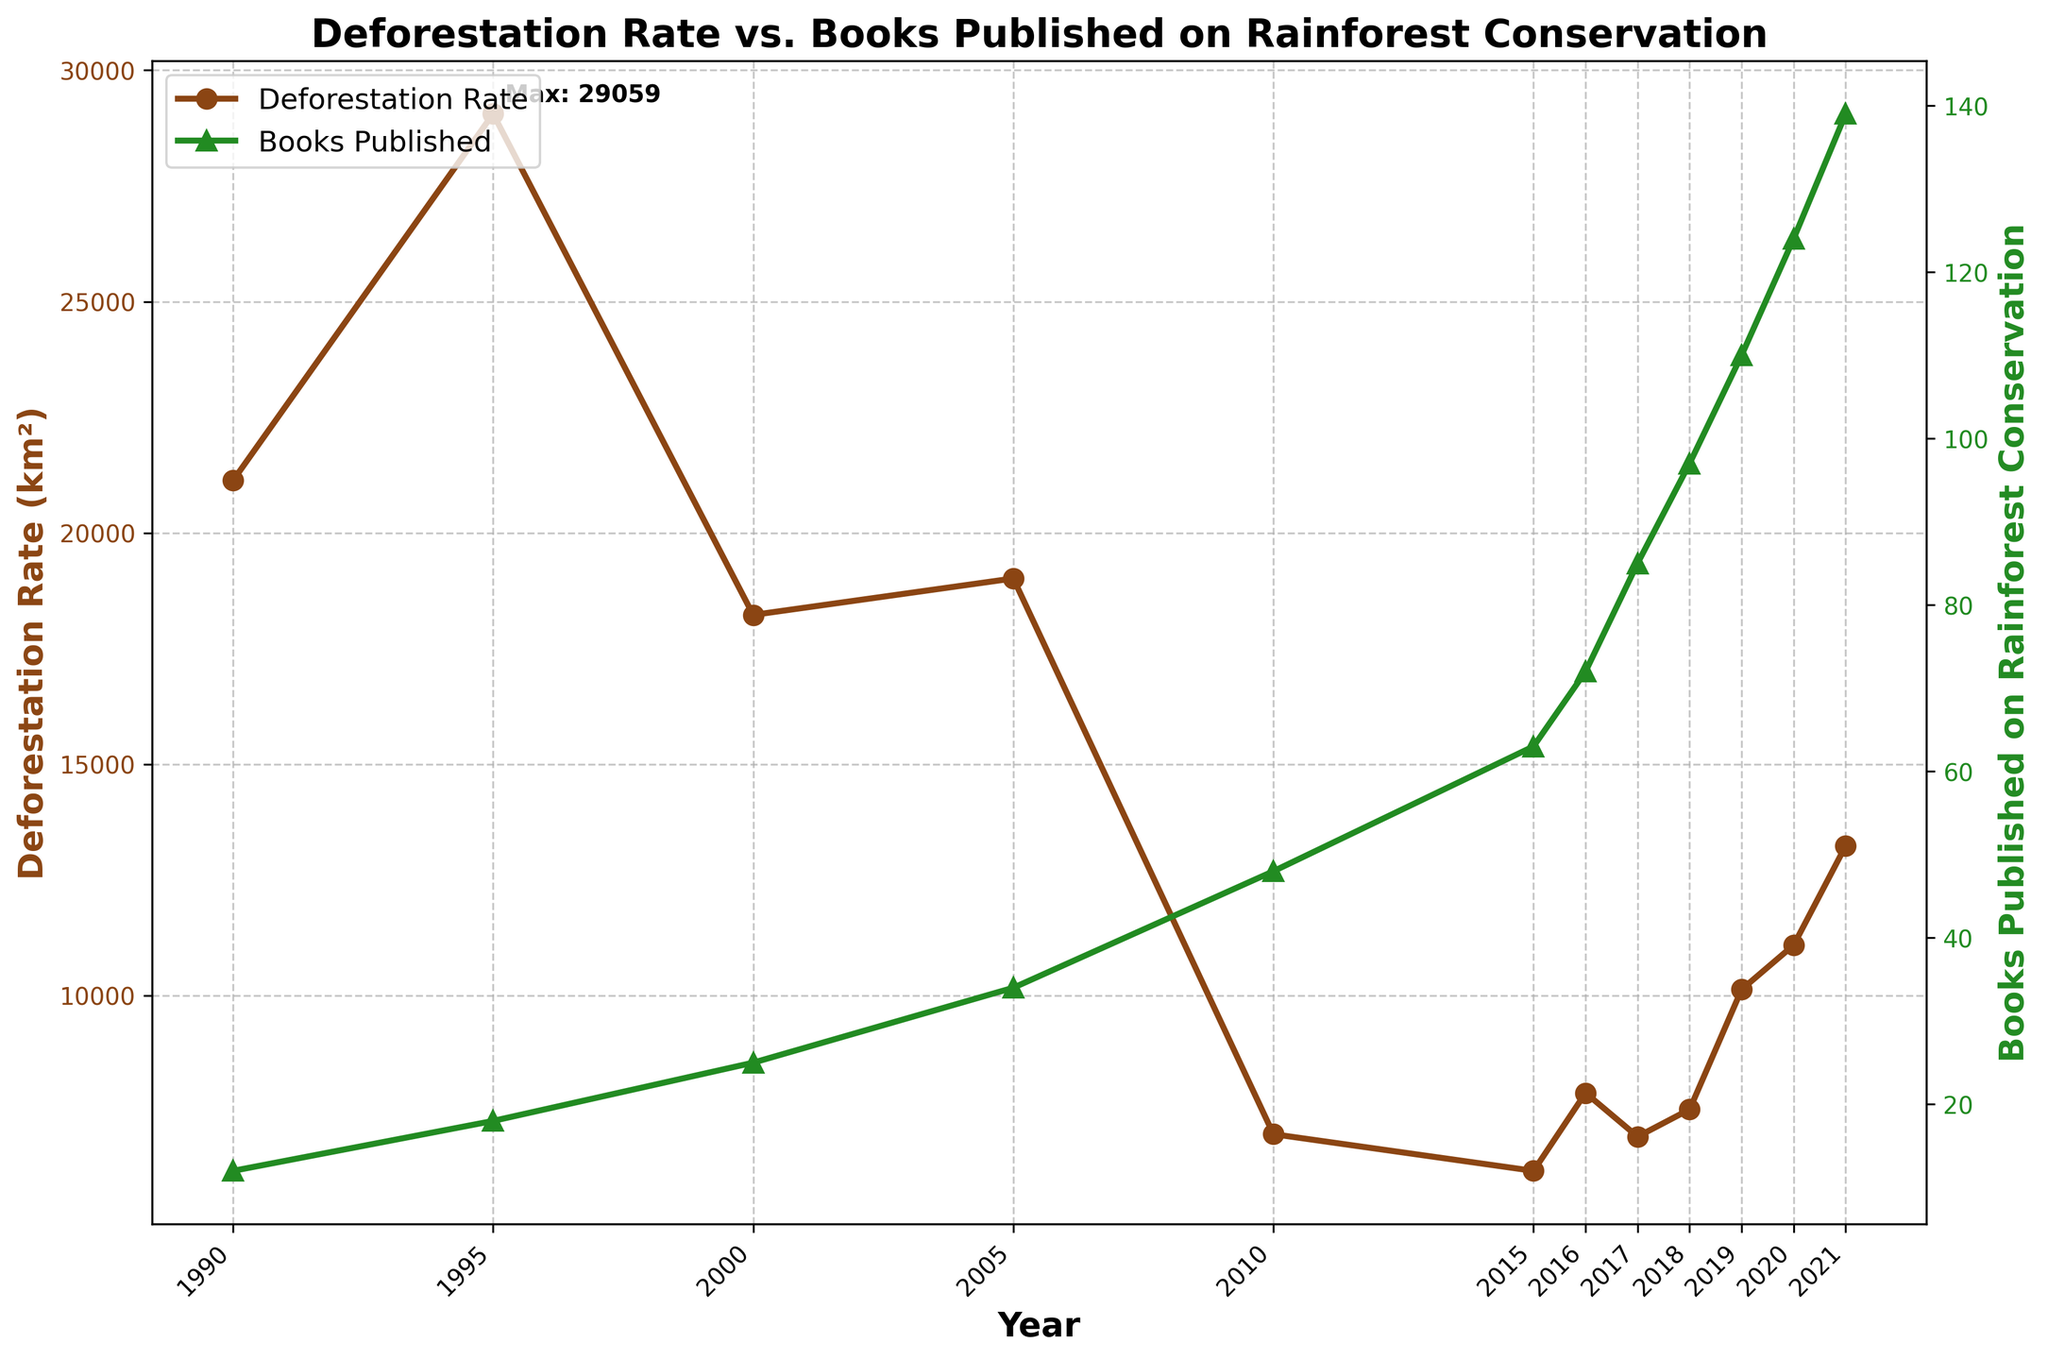What year had the highest rate of deforestation? By looking at the line representing the deforestation rate, the highest point is annotated. This point corresponds to the year with the highest rate.
Answer: 1995 How did the deforestation rate change from 1995 to 2000? Observe the deforestation rate values in 1995 and 2000 on the chart and calculate the difference. The rate in 1995 was 29059 km², and in 2000 it was 18226 km². Thus, the change can be found by subtracting 18226 from 29059.
Answer: Decreased by 10833 km² Between which two consecutive years did the number of published books on rainforest conservation increase the most? Look at the line representing book publications and identify where the steepest slope between consecutive years occurs. Comparing all increases year by year, the most significant jump is between 2019 (110 books) and 2020 (124 books), an increase of 14 books.
Answer: 2019 to 2020 Was the deforestation rate at its lowest when the number of books published was the highest? Locate the lowest point on the deforestation rate line, which is in 2015, and see the corresponding point on the publications line. Then, find the highest point on the publications line and compare the deforestation rates in these years. In 2021, the number of books published was highest (139), while 2015 had the lowest deforestation (6207 km²).
Answer: No What is the trend of the number of books published from 1990 to 2021? Examine the line showing the number of books published and observe its general direction. The number of books published consistently increases over the years from 12 in 1990 to 139 in 2021.
Answer: Increasing trend How did the deforestation rate change between 2010 and 2011? The chart only provides data points until 2021, so it must be assumed that there is no additional data for 2011. Given the closest referenced years, between 2010 (7000 km²) and 2015 (6207 km²), the exact rate of change for 2011 cannot be determined directly. Hence this question is invalid and should be skipped for the given data.
Answer: Invalid question (no data for 2011) What year saw a drop in deforestation rates but an increase in books published? Identify years where the deforestation line goes down while the books published line goes up. For example, between 2017 (6947 km²) to 2018 (7536 km²), books published increased from 85 to 97.
Answer: 2015 How much did the mean deforestation rate change per year from 2000 to 2021? Calculate the mean deforestation rate across the given range of years. Sum all deforestation rates from 2000 to 2021 and divide by the number of years. First, sum the deforestation rates [(18226 + 19014 + 7000 + 6207 + 7893 + 6947 + 7536 + 10129 + 11088 + 13235) = 109275], then divide by 11 years.
Answer: Approximately 9934 km² per year What was the biggest difference between the deforestation rate and the number of books published in any given year? For each year, calculate the absolute difference between the deforestation rate and the number of books published. Identify the maximum difference. Comparing all values, the highest difference is in 1995 (29059 deforestation, 18 books published), with an absolute difference of 29041.
Answer: 29041 How many more books were published in 2021 compared to 1990? Find the number of books published in 2021 and 1990 on the chart and compute the difference by subtracting the two values (139 books in 2021 and 12 books in 1990).
Answer: 127 more books 